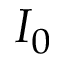Convert formula to latex. <formula><loc_0><loc_0><loc_500><loc_500>I _ { 0 }</formula> 